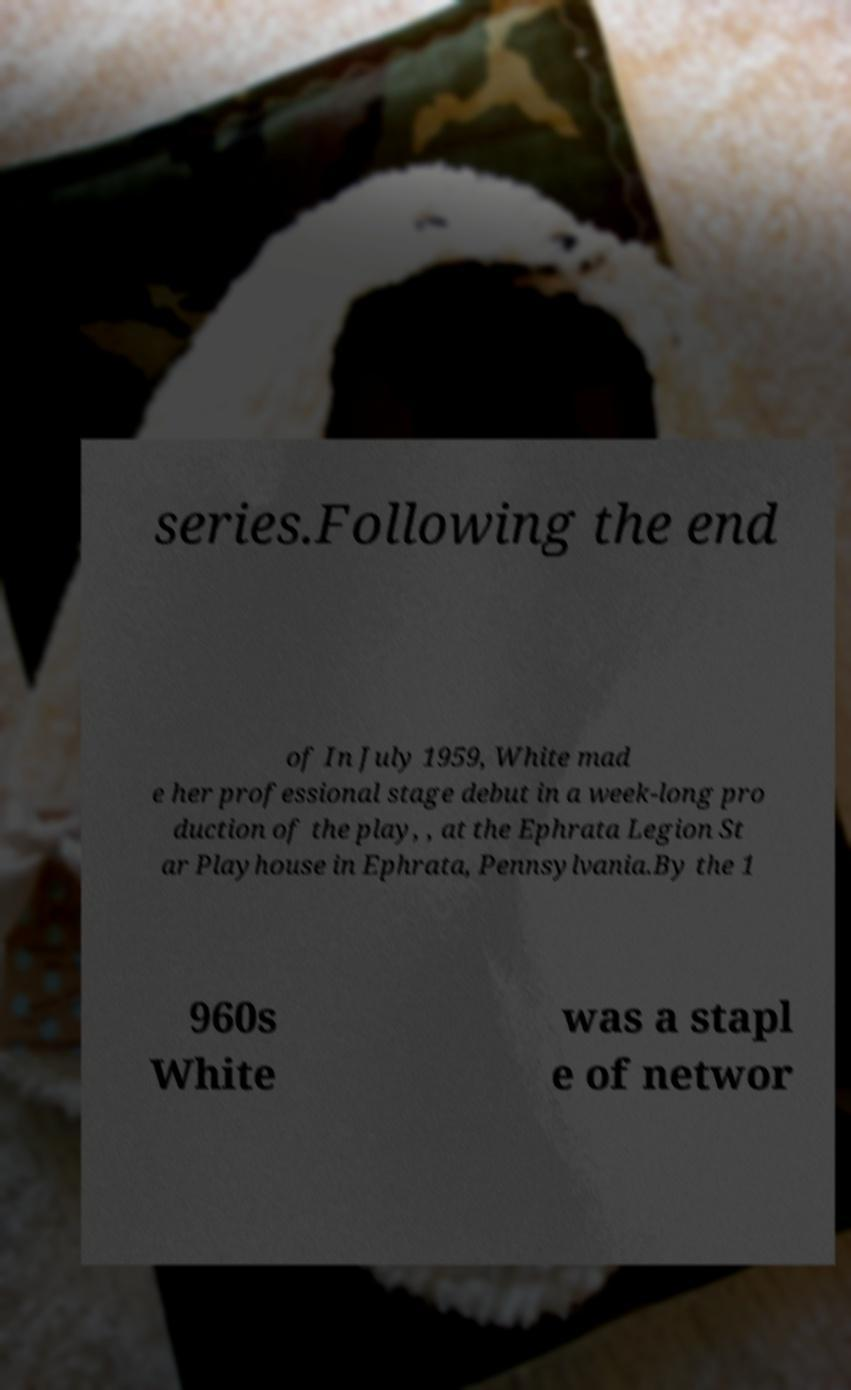There's text embedded in this image that I need extracted. Can you transcribe it verbatim? series.Following the end of In July 1959, White mad e her professional stage debut in a week-long pro duction of the play, , at the Ephrata Legion St ar Playhouse in Ephrata, Pennsylvania.By the 1 960s White was a stapl e of networ 